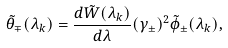Convert formula to latex. <formula><loc_0><loc_0><loc_500><loc_500>\tilde { \theta } _ { \mp } ( \lambda _ { k } ) = \frac { d \tilde { W } ( \lambda _ { k } ) } { d \lambda } ( \gamma _ { \pm } ) ^ { 2 } \tilde { \phi } _ { \pm } ( \lambda _ { k } ) ,</formula> 